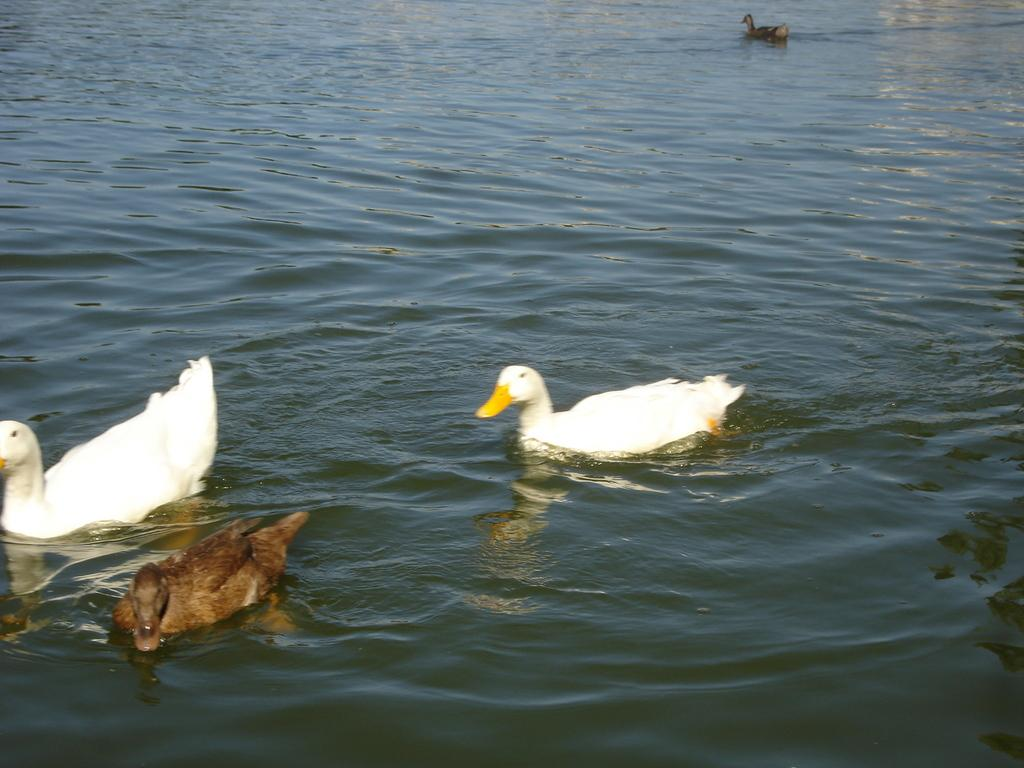What is present in the image that is not solid? There is water visible in the image. What is on the water in the image? There are birds on the surface of the water. What colors can be seen on the birds in the image? The birds have white, black, and brown colors. How much debt do the birds in the image have? There is no information about the birds' debt in the image, as it does not involve financial matters. 